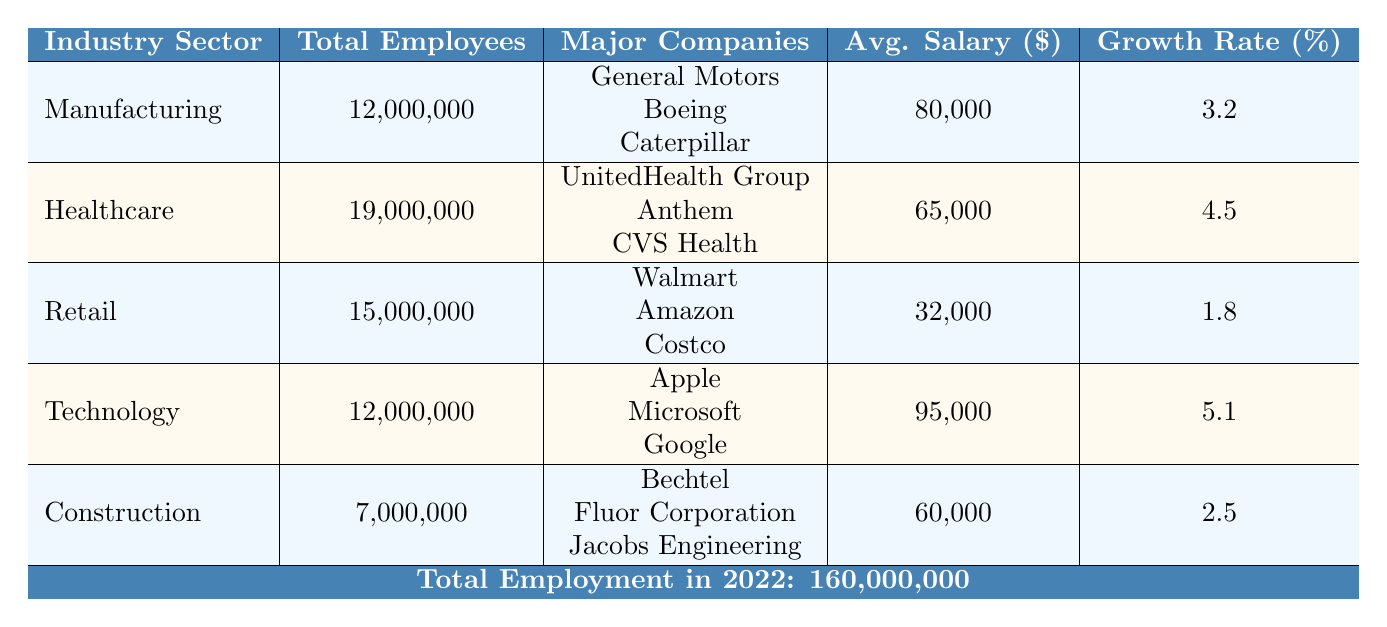What is the total number of employees in the Healthcare sector? Referring to the table, the Healthcare sector lists "Total Employees" as 19,000,000.
Answer: 19,000,000 Which industry sector has the highest average salary? The table shows the average salaries for Manufacturing ($80,000), Healthcare ($65,000), Retail ($32,000), Technology ($95,000), and Construction ($60,000). The highest average salary is in the Technology sector at $95,000.
Answer: Technology How many employees work in the Retail sector compared to the Construction sector? The Retail sector has 15,000,000 employees and the Construction sector has 7,000,000 employees. To find the difference: 15,000,000 - 7,000,000 = 8,000,000 more employees in Retail than Construction.
Answer: 8,000,000 Is there any sector with more than 10 million employees? By looking at the total employees listed for each sector: Manufacturing (12,000,000), Healthcare (19,000,000), Retail (15,000,000), Technology (12,000,000), and Construction (7,000,000), it's clear that Manufacturing, Healthcare, Retail, and Technology all have more than 10 million employees. Therefore, there are sectors with over 10 million employees.
Answer: Yes What is the average growth rate of the Manufacturing and Construction sectors combined? The Manufacturing sector has a growth rate of 3.2%, and the Construction sector has a growth rate of 2.5%. To find the average growth rate: (3.2 + 2.5) / 2 = 5.7 / 2 = 2.85%.
Answer: 2.85% What percentage of total employment is represented by the Healthcare sector? The total employment is 160,000,000 and the Healthcare sector has 19,000,000 employees. To calculate the percentage: (19,000,000 / 160,000,000) * 100 = 11.875%.
Answer: 11.88% Which sector employs fewer people: Technology or Manufacturing? Technology has 12,000,000 employees and Manufacturing also has 12,000,000 employees. Since both have the same number of employees, we can say neither employs fewer people; they are equal.
Answer: Neither Are there fewer employees in the Retail sector than in the Manufacturing sector? The Retail sector has 15,000,000 employees while the Manufacturing sector has 12,000,000 employees. Since 15,000,000 is greater than 12,000,000, there are not fewer employees in Retail than in Manufacturing.
Answer: No 